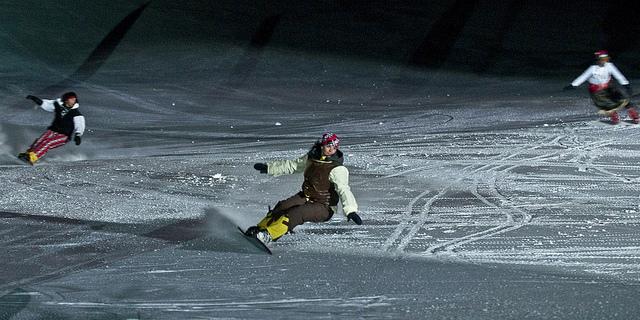Are these people holding ski poles?
Give a very brief answer. No. How many people are there?
Give a very brief answer. 3. Are they going down or up?
Write a very short answer. Down. 